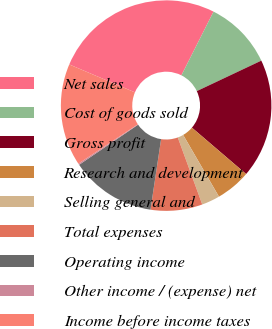<chart> <loc_0><loc_0><loc_500><loc_500><pie_chart><fcel>Net sales<fcel>Cost of goods sold<fcel>Gross profit<fcel>Research and development<fcel>Selling general and<fcel>Total expenses<fcel>Operating income<fcel>Other income / (expense) net<fcel>Income before income taxes<nl><fcel>26.04%<fcel>10.54%<fcel>18.29%<fcel>5.37%<fcel>2.79%<fcel>7.95%<fcel>13.12%<fcel>0.2%<fcel>15.7%<nl></chart> 